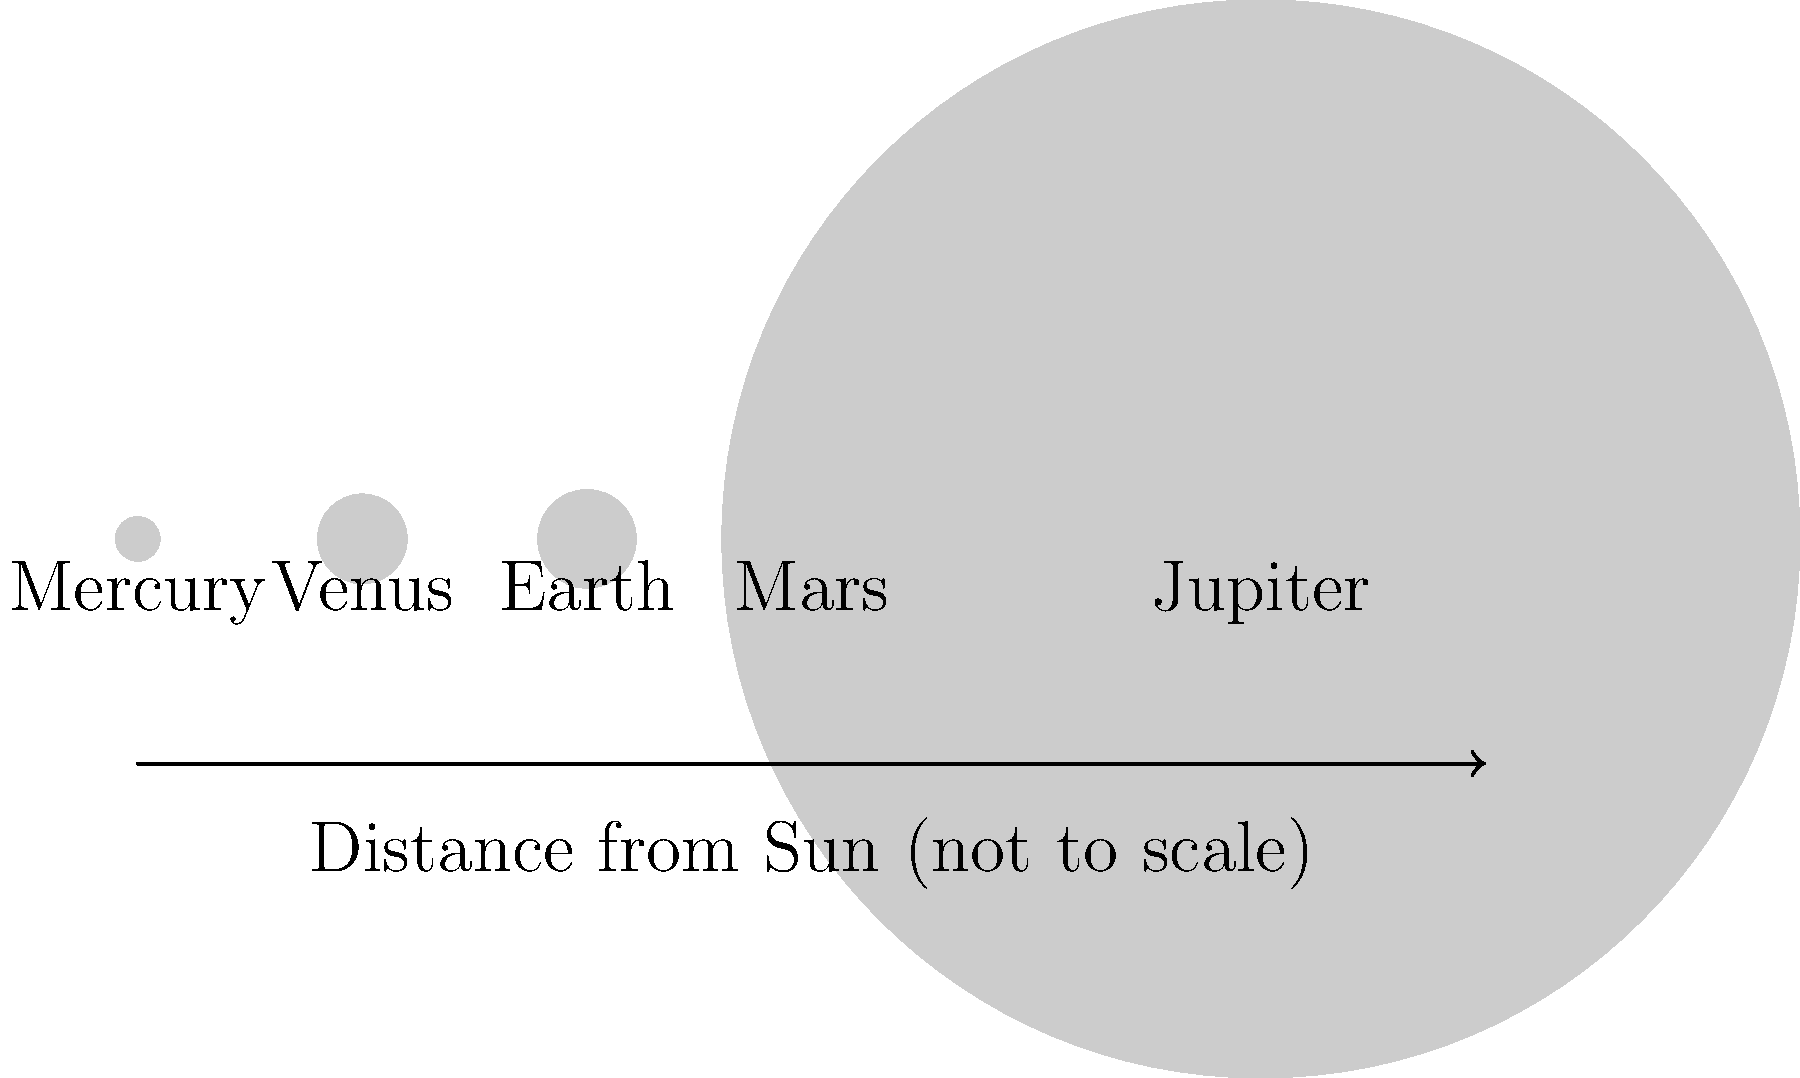In a screenplay about space exploration, you're advising on a scene discussing planetary sizes. Which planet in our solar system is significantly larger than Earth, and how does its size compare to the terrestrial planets shown in the diagram? To answer this question, let's analyze the diagram step-by-step:

1. The diagram shows five planets: Mercury, Venus, Earth, Mars, and Jupiter.

2. The sizes of the planets are represented by circles of different diameters.

3. We can see that Mercury, Venus, Earth, and Mars are relatively close in size, with Earth and Venus being the largest of these four.

4. Jupiter, however, is depicted with a much larger circle, indicating it's significantly larger than the other planets shown.

5. In reality, Jupiter is indeed much larger than the terrestrial planets (Mercury, Venus, Earth, and Mars). 

6. To quantify this difference:
   - Jupiter's diameter is about 11 times that of Earth.
   - Jupiter's volume is about 1,321 times that of Earth.

7. The diagram is not to scale in terms of distances between planets, but it accurately represents the relative size difference between Jupiter and the terrestrial planets.

Therefore, Jupiter is the planet significantly larger than Earth in our solar system, and it's over 11 times larger in diameter than any of the terrestrial planets shown in the diagram.
Answer: Jupiter; over 11 times larger in diameter than Earth 